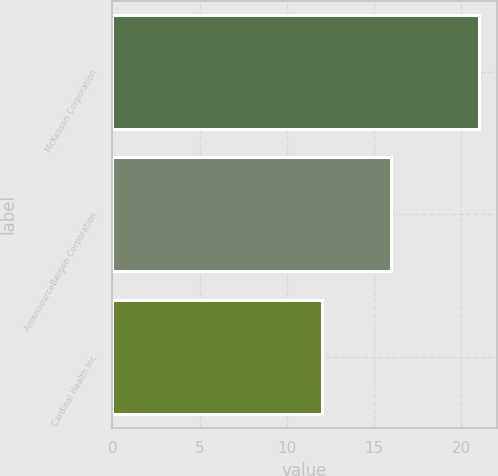Convert chart. <chart><loc_0><loc_0><loc_500><loc_500><bar_chart><fcel>McKesson Corporation<fcel>AmerisourceBergen Corporation<fcel>Cardinal Health Inc<nl><fcel>21<fcel>16<fcel>12<nl></chart> 